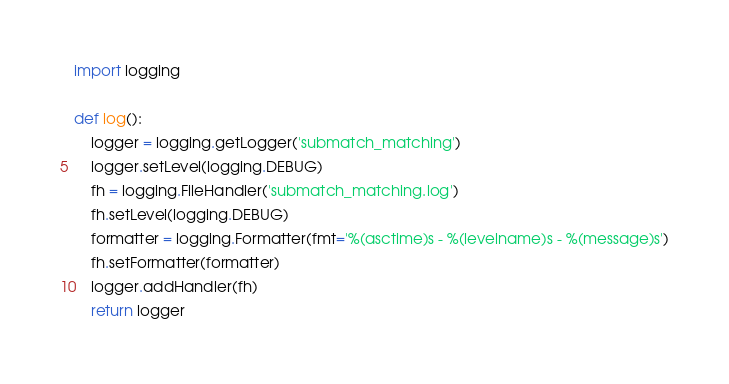Convert code to text. <code><loc_0><loc_0><loc_500><loc_500><_Python_>import logging

def log():
	logger = logging.getLogger('submatch_matching')
	logger.setLevel(logging.DEBUG)
	fh = logging.FileHandler('submatch_matching.log')
	fh.setLevel(logging.DEBUG)
	formatter = logging.Formatter(fmt='%(asctime)s - %(levelname)s - %(message)s')
	fh.setFormatter(formatter)
	logger.addHandler(fh)
	return logger</code> 